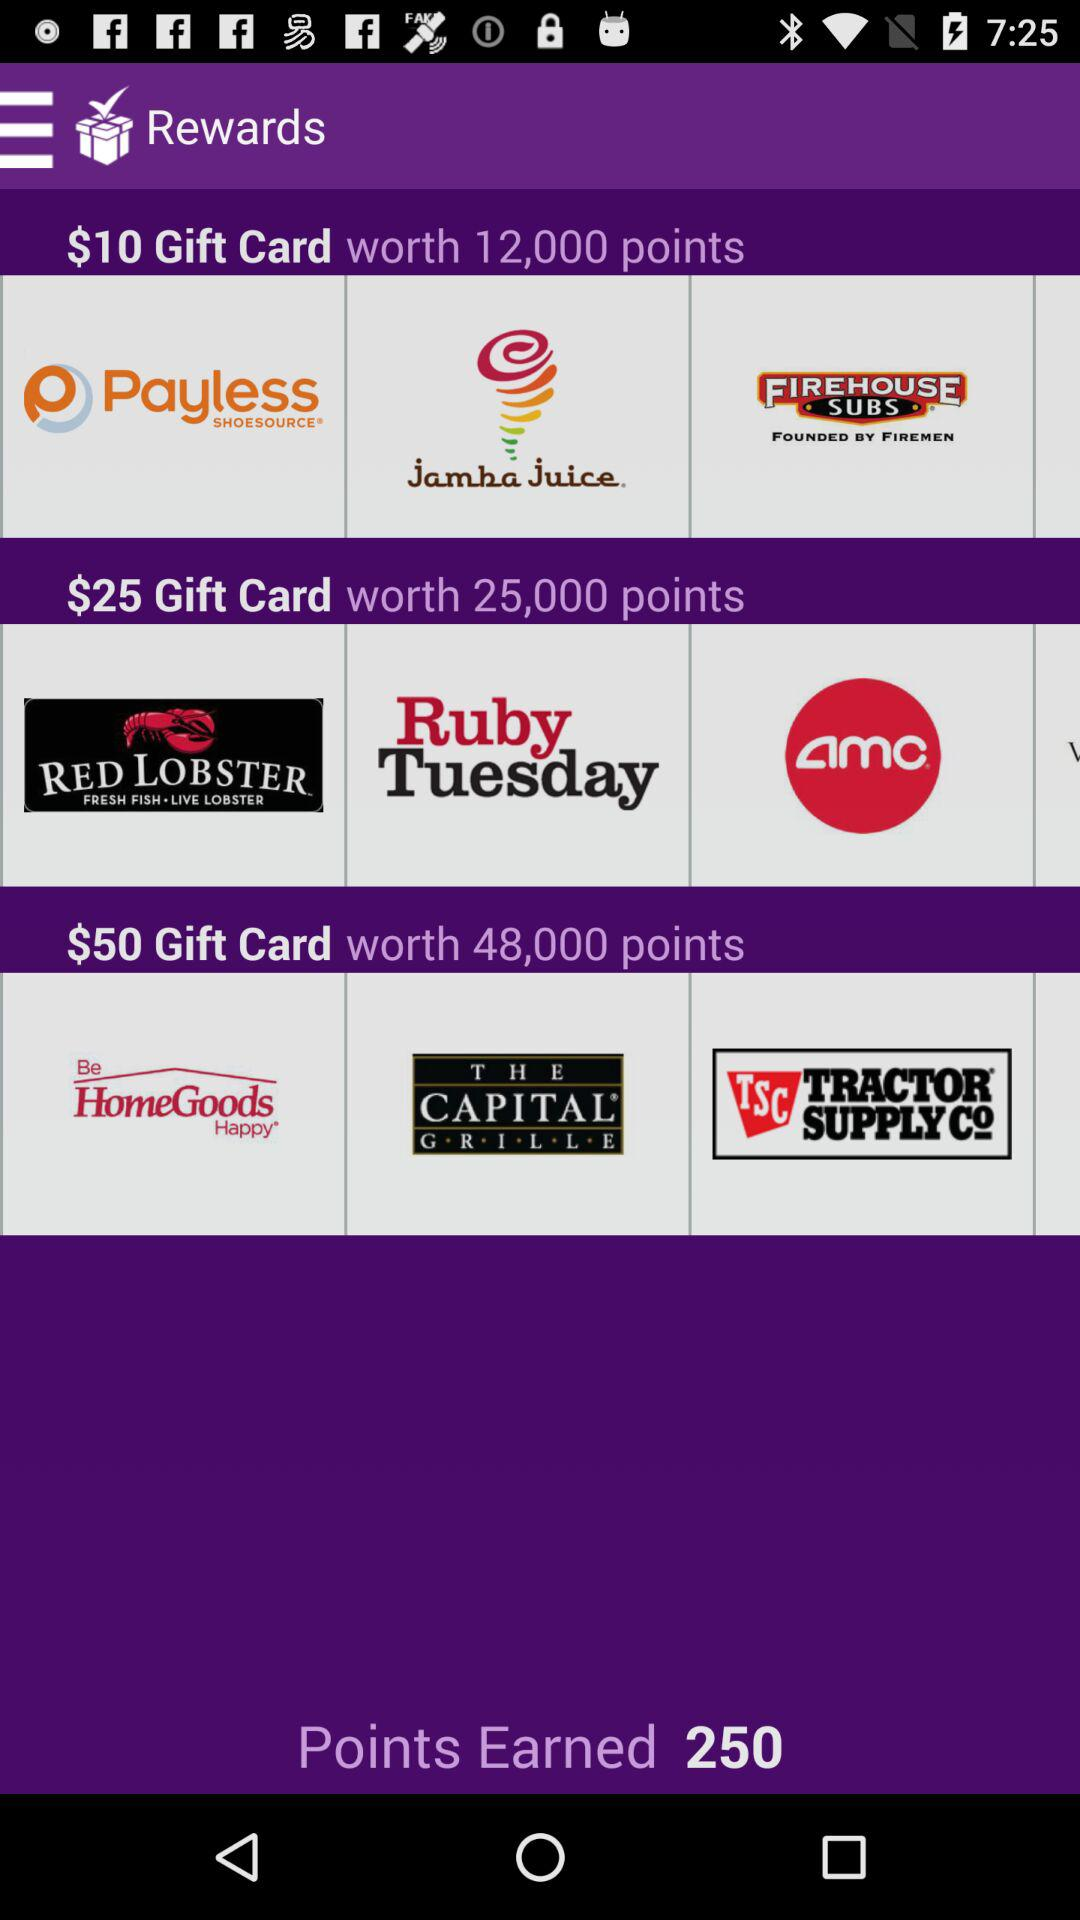Which reward did the user select?
When the provided information is insufficient, respond with <no answer>. <no answer> 